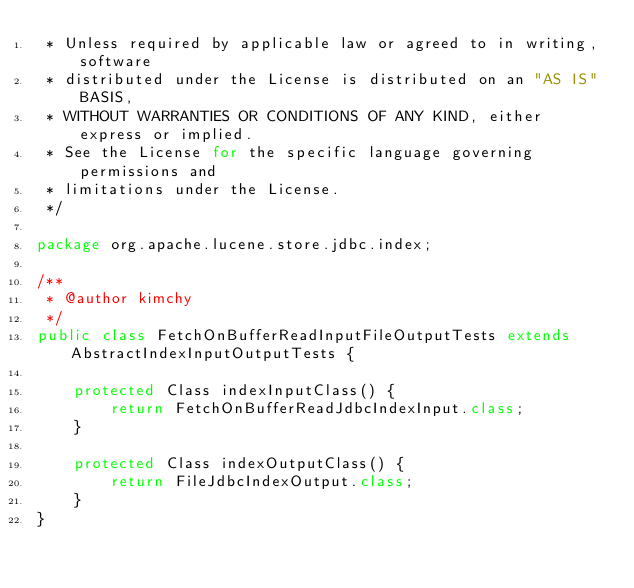<code> <loc_0><loc_0><loc_500><loc_500><_Java_> * Unless required by applicable law or agreed to in writing, software
 * distributed under the License is distributed on an "AS IS" BASIS,
 * WITHOUT WARRANTIES OR CONDITIONS OF ANY KIND, either express or implied.
 * See the License for the specific language governing permissions and
 * limitations under the License.
 */

package org.apache.lucene.store.jdbc.index;

/**
 * @author kimchy
 */
public class FetchOnBufferReadInputFileOutputTests extends AbstractIndexInputOutputTests {

    protected Class indexInputClass() {
        return FetchOnBufferReadJdbcIndexInput.class;
    }

    protected Class indexOutputClass() {
        return FileJdbcIndexOutput.class;
    }
}
</code> 